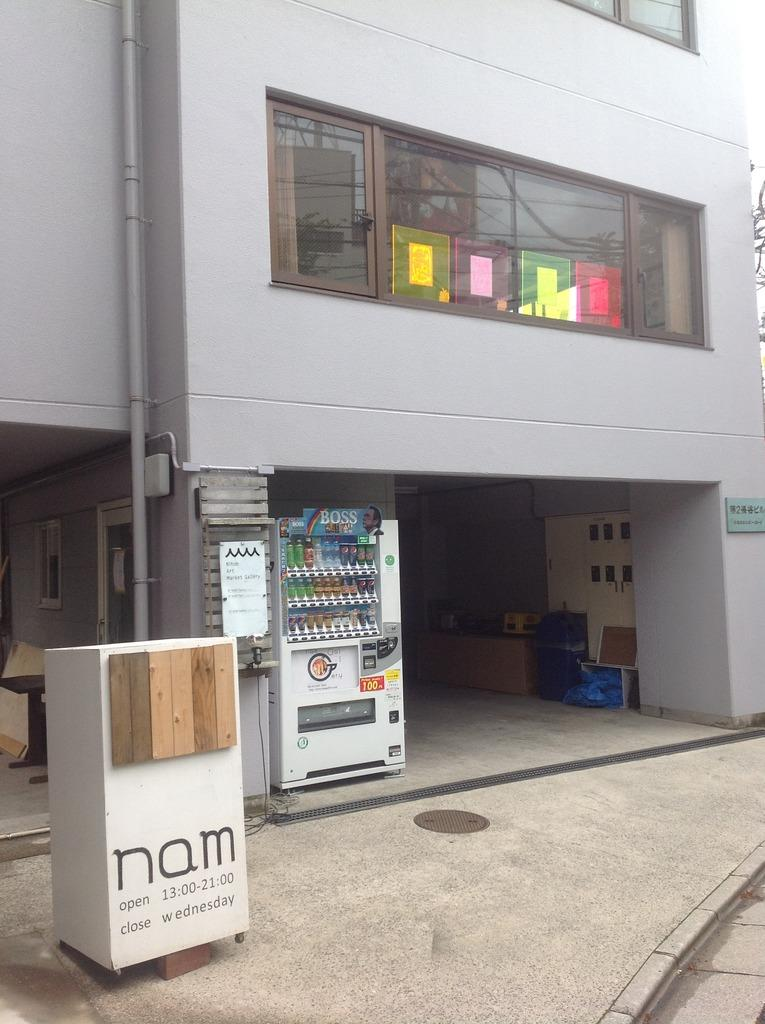What type of structure is visible in the image? There is a building in the image. What feature can be seen on the building? The building has windows. What other objects are present in the image? There are boards, boxes, and bottles in the image. What is at the bottom of the image? There is a floor at the bottom of the image. What direction is the moon facing in the image? There is no moon present in the image. What time of day is depicted in the image? The time of day cannot be determined from the image, as there are no specific clues or indicators. 